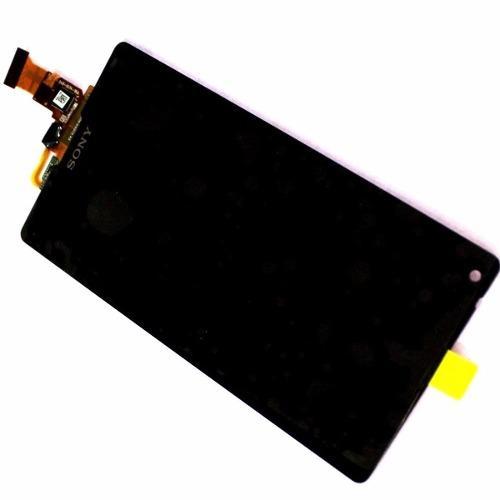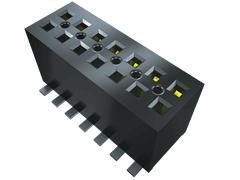The first image is the image on the left, the second image is the image on the right. For the images shown, is this caption "The container in the image on the left is open." true? Answer yes or no. No. 